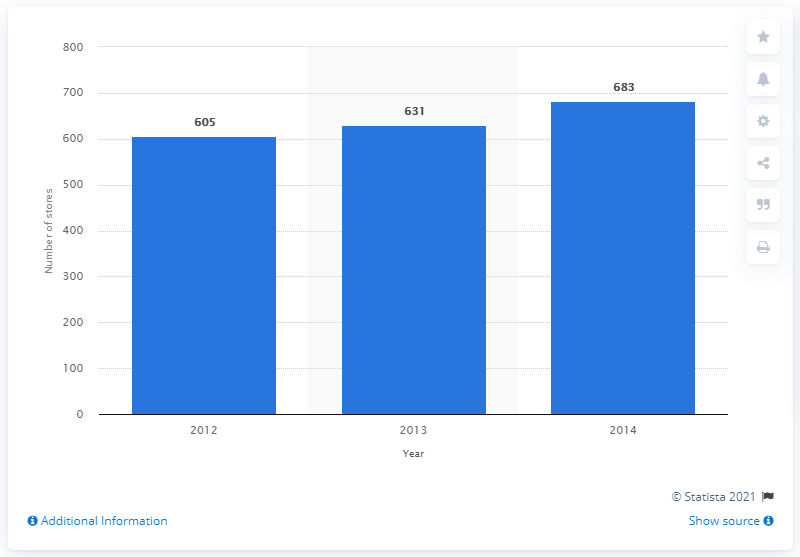Specify some key components in this picture. In 2012, Quiksilver operated a total of 605 stores worldwide. In 2014, Quiksilver operated a total of 683 stores. 